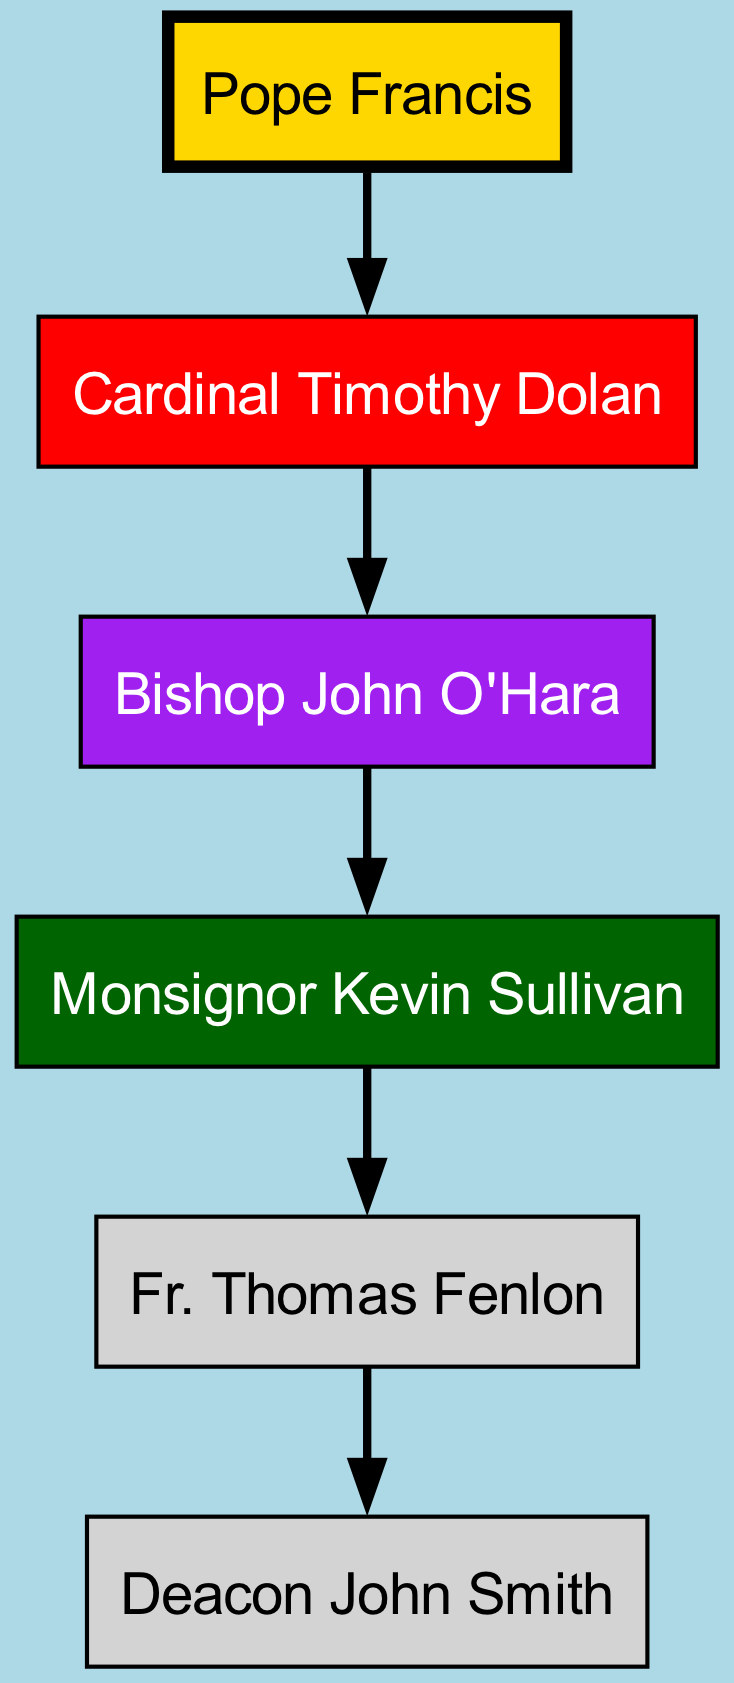What is the top position in the hierarchy? The diagram clearly shows "Pope Francis" at the top of the structure, indicating his position as the highest authority in the Catholic Church.
Answer: Pope Francis Who is directly below the Pope? "Cardinal Timothy Dolan" is the immediate subordinate to the Pope, linking the two positions directly.
Answer: Cardinal Timothy Dolan How many levels are there in this hierarchy? Counting from the Pope down to the deacon, there are five distinct levels: Pope, Cardinal, Bishop, Monsignor, and Deacon.
Answer: Five What is the role directly above Fr. Thomas Fenlon? The diagram indicates that "Monsignor Kevin Sullivan" holds the position directly above Fr. Thomas Fenlon in the hierarchy.
Answer: Monsignor Kevin Sullivan Who is the lowest position in this hierarchy? "Deacon John Smith" is the lowest rank shown in the diagram, indicating the final tier in this specific structure.
Answer: Deacon John Smith Which individual is both a Bishop and is above Monsignor Kevin Sullivan? "Bishop John O'Hara" is the individual who occupies the position above the Monsignor, indicating a clear hierarchical relationship.
Answer: Bishop John O'Hara How many total positions are shown in the hierarchy? There are six positions: Pope, Cardinal, Bishop, Monsignor, Fr. Thomas Fenlon, and Deacon John Smith, which sums up to a total of six distinct roles.
Answer: Six What color is used for the node representing the Pope? The diagram specifies that the node for the Pope is filled with a gold color, indicating its prominence in the hierarchy.
Answer: Gold Which cardinal is specifically mentioned in the hierarchy? "Cardinal Timothy Dolan" is the cardinal that is explicitly depicted in the hierarchy chart, showing his significant role.
Answer: Cardinal Timothy Dolan 